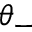<formula> <loc_0><loc_0><loc_500><loc_500>\theta _ { - }</formula> 